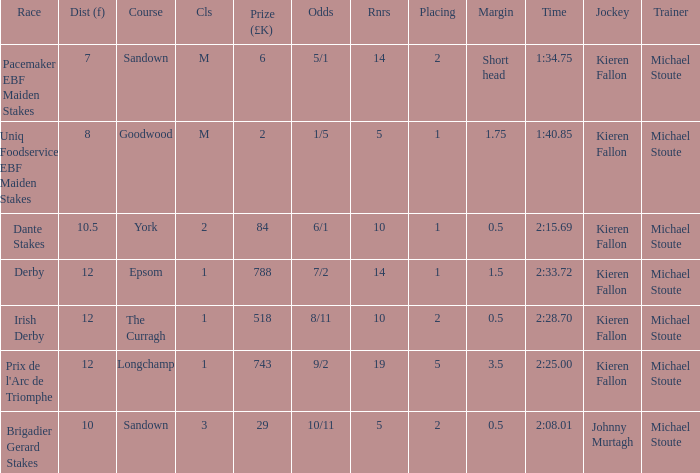Name the runners for longchamp 19.0. 